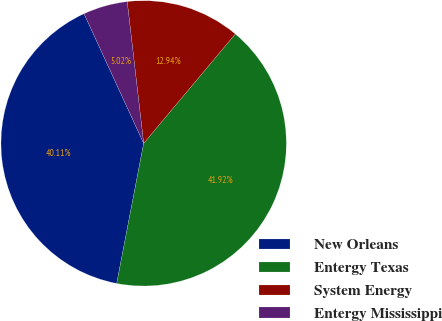Convert chart. <chart><loc_0><loc_0><loc_500><loc_500><pie_chart><fcel>New Orleans<fcel>Entergy Texas<fcel>System Energy<fcel>Entergy Mississippi<nl><fcel>40.11%<fcel>41.92%<fcel>12.94%<fcel>5.02%<nl></chart> 